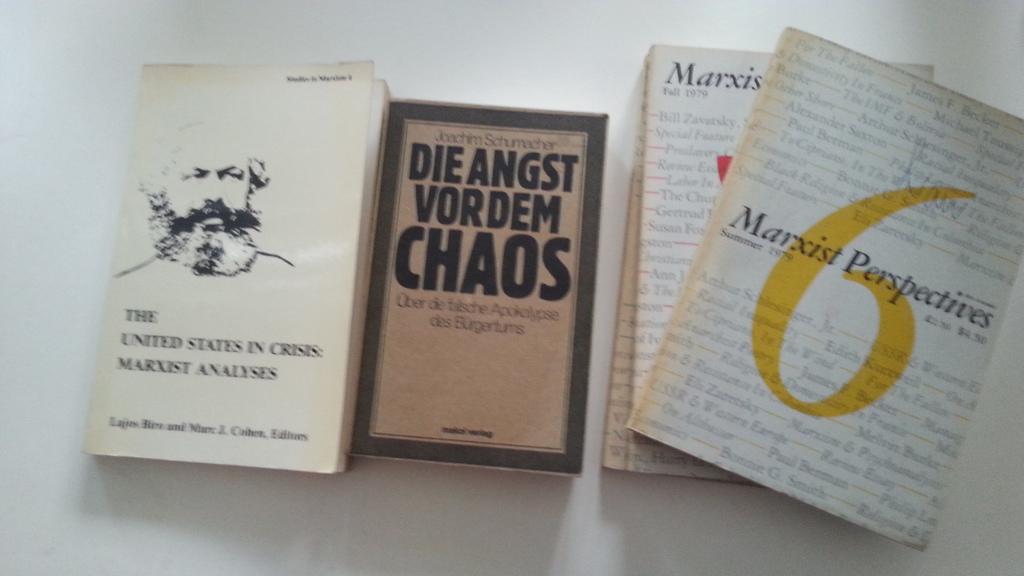What is the middle book?
Your answer should be compact. Die angst vordem chaos. What yellow number is on the cover of the book on the right?
Your answer should be compact. 6. 